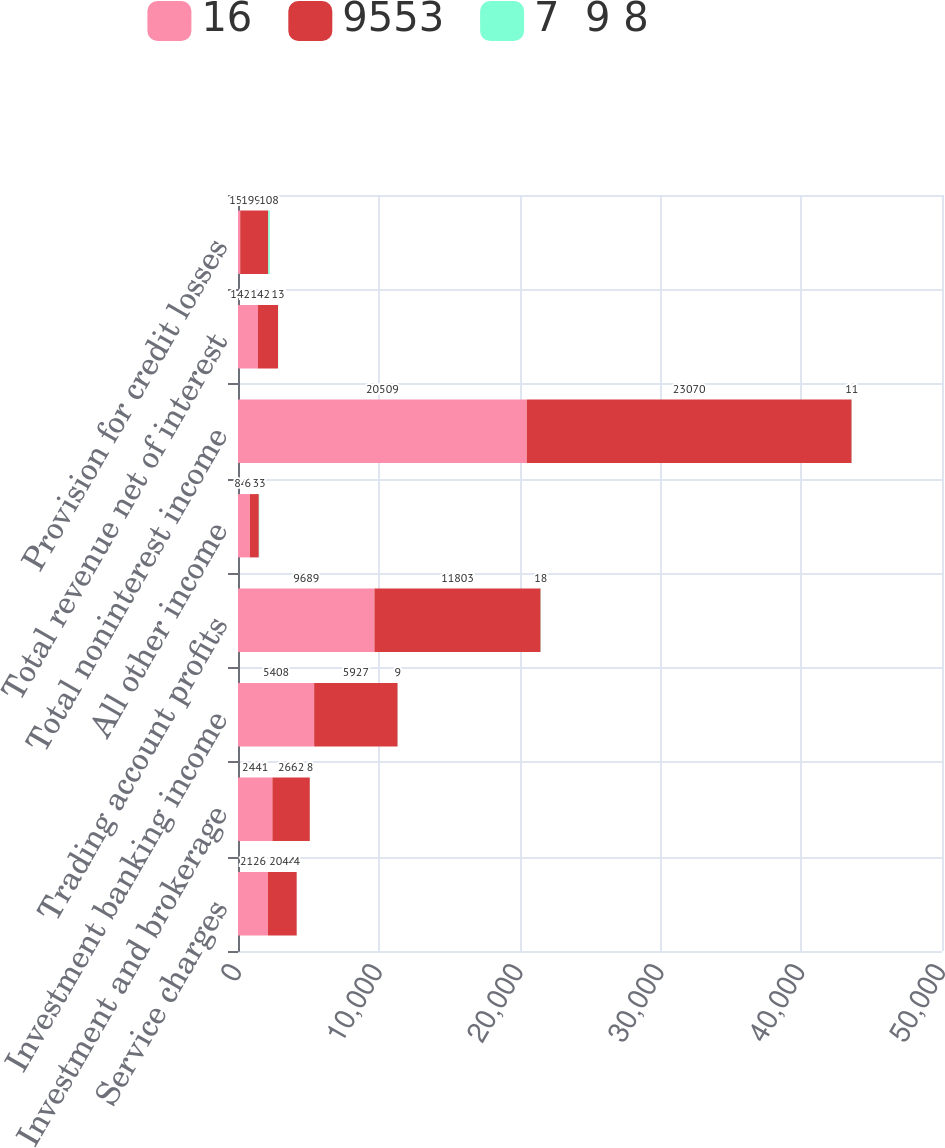Convert chart to OTSL. <chart><loc_0><loc_0><loc_500><loc_500><stacked_bar_chart><ecel><fcel>Service charges<fcel>Investment and brokerage<fcel>Investment banking income<fcel>Trading account profits<fcel>All other income<fcel>Total noninterest income<fcel>Total revenue net of interest<fcel>Provision for credit losses<nl><fcel>16<fcel>2126<fcel>2441<fcel>5408<fcel>9689<fcel>845<fcel>20509<fcel>1421.5<fcel>155<nl><fcel>9553<fcel>2044<fcel>2662<fcel>5927<fcel>11803<fcel>634<fcel>23070<fcel>1421.5<fcel>1998<nl><fcel>7  9 8<fcel>4<fcel>8<fcel>9<fcel>18<fcel>33<fcel>11<fcel>13<fcel>108<nl></chart> 